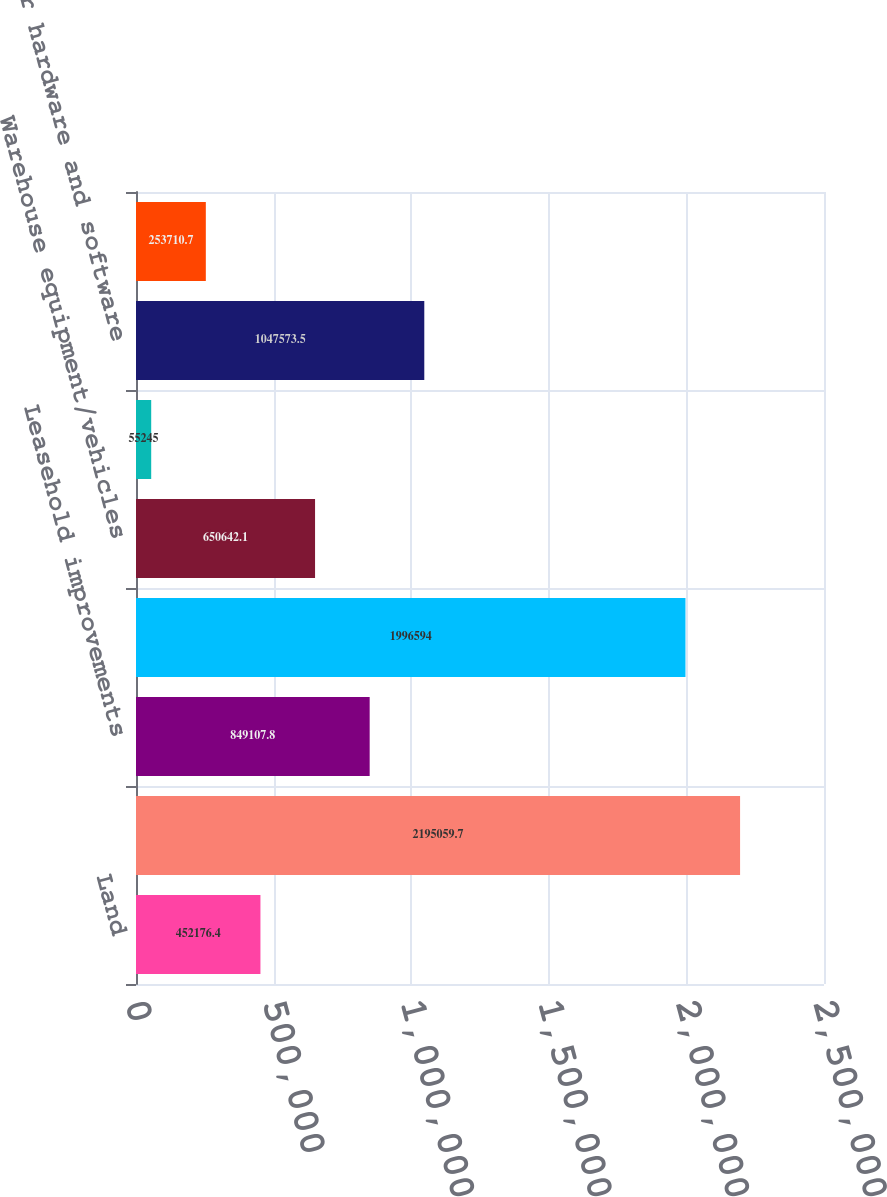Convert chart. <chart><loc_0><loc_0><loc_500><loc_500><bar_chart><fcel>Land<fcel>Buildings and building<fcel>Leasehold improvements<fcel>Racking<fcel>Warehouse equipment/vehicles<fcel>Furniture and fixtures<fcel>Computer hardware and software<fcel>Construction in progress<nl><fcel>452176<fcel>2.19506e+06<fcel>849108<fcel>1.99659e+06<fcel>650642<fcel>55245<fcel>1.04757e+06<fcel>253711<nl></chart> 